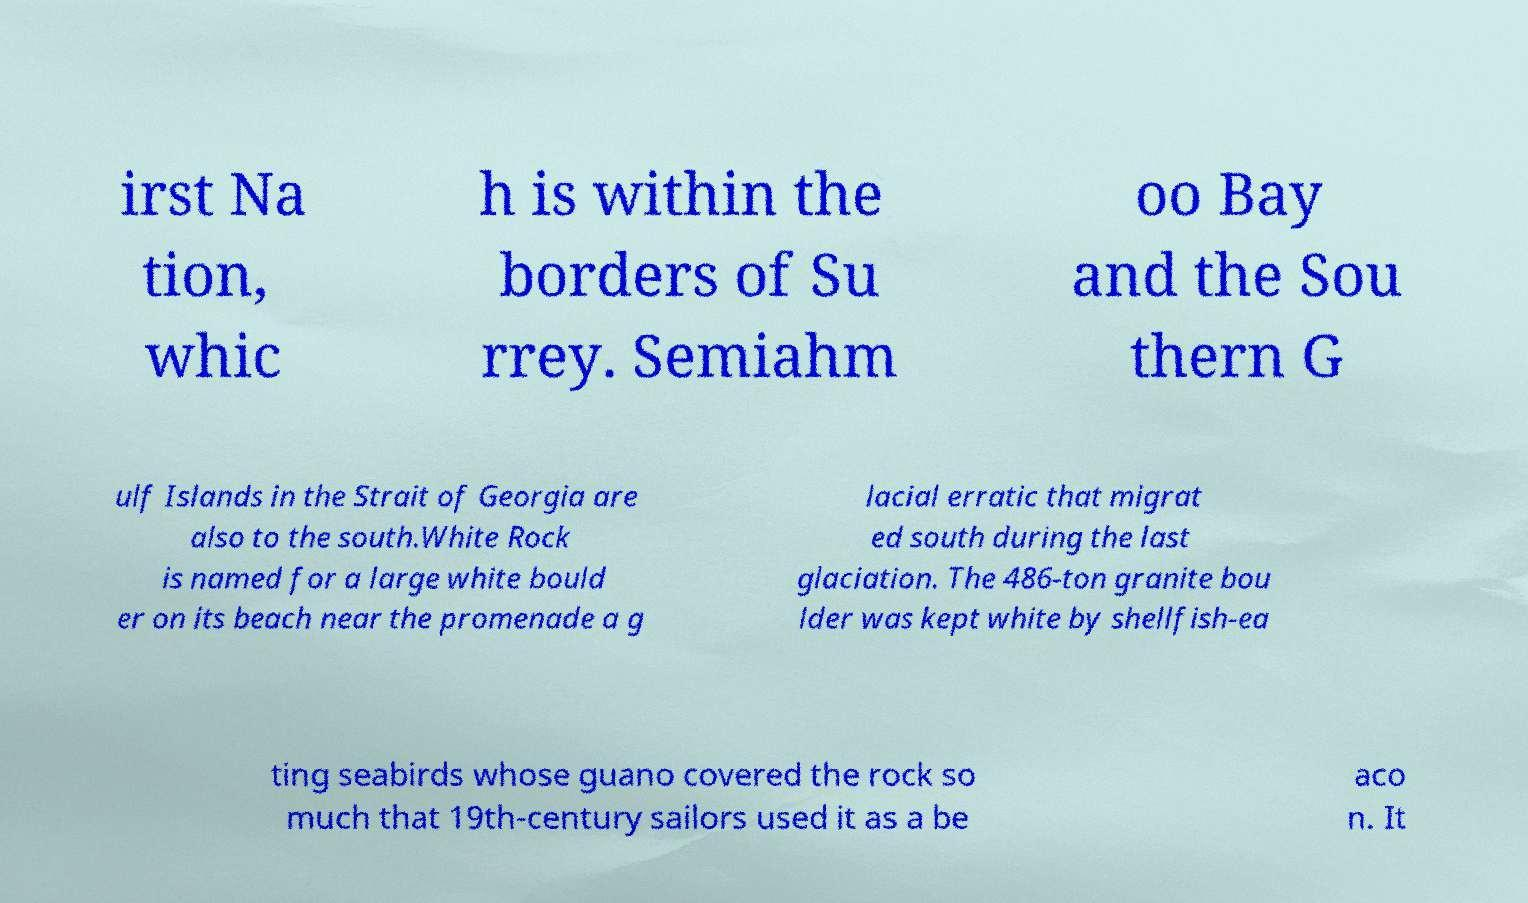There's text embedded in this image that I need extracted. Can you transcribe it verbatim? irst Na tion, whic h is within the borders of Su rrey. Semiahm oo Bay and the Sou thern G ulf Islands in the Strait of Georgia are also to the south.White Rock is named for a large white bould er on its beach near the promenade a g lacial erratic that migrat ed south during the last glaciation. The 486-ton granite bou lder was kept white by shellfish-ea ting seabirds whose guano covered the rock so much that 19th-century sailors used it as a be aco n. It 